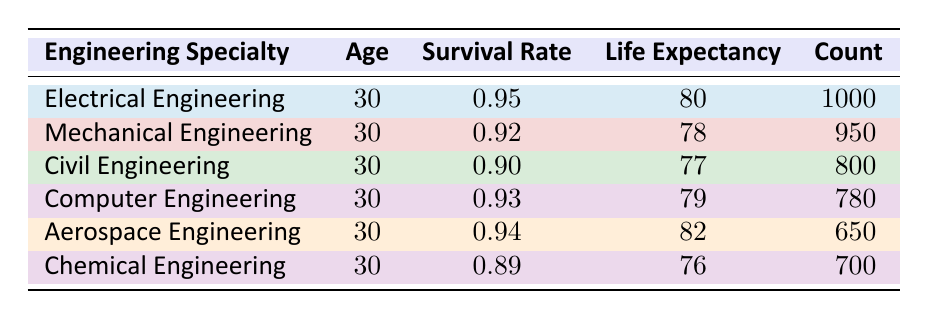What is the survival rate for Chemical Engineering? The table shows the survival rates for each engineering specialty. For Chemical Engineering, the survival rate is listed as 0.89.
Answer: 0.89 Which engineering specialty has the highest life expectancy? By examining the "Life Expectancy" column, Aerospace Engineering has the highest value of 82.
Answer: Aerospace Engineering What is the average survival rate of all engineering specialties listed? First, we add the survival rates: 0.95 + 0.92 + 0.90 + 0.93 + 0.94 + 0.89 = 5.53. There are 6 specialties, so we divide the sum by 6: 5.53 / 6 = 0.9217.
Answer: 0.9217 Is the survival rate for Electrical Engineering greater than that of Mechanical Engineering? The survival rate for Electrical Engineering is 0.95 and for Mechanical Engineering, it is 0.92. Since 0.95 is greater than 0.92, the statement is true.
Answer: Yes What is the difference in life expectancy between Civil Engineering and Computer Engineering? The life expectancy for Civil Engineering is 77 years and for Computer Engineering, it is 79 years. The difference is calculated as 79 - 77 = 2 years.
Answer: 2 years Which engineering specialty has a count less than 800? By referring to the "Count" column, Civil Engineering has a count of 800, while the other specialties have counts of 780 or below. Therefore, any engineering specialty with a count less than 800 matches this criteria. The only ones are Computer Engineering (780) and Aerospace Engineering (650).
Answer: Computer and Aerospace Engineering What is the total count of individuals for all engineering specialties combined? We sum the counts from all specialties: 1000 + 950 + 800 + 780 + 650 + 700 = 4180. Therefore, the total count is 4180.
Answer: 4180 Is the survival rate for Aerospace Engineering more than 0.91? The survival rate for Aerospace Engineering is 0.94. Since 0.94 is greater than 0.91, the statement is true.
Answer: Yes What is the survival rate of the specialty with the lowest life expectancy? The table indicates that Chemical Engineering has the lowest life expectancy of 76 years. The survival rate for Chemical Engineering is 0.89.
Answer: 0.89 What percentage of individuals in the table are in Electrical Engineering? To find the percentage, we divide the count for Electrical Engineering (1000) by the total count (4180) and multiply by 100: (1000 / 4180) * 100 ≈ 23.9%.
Answer: 23.9% 